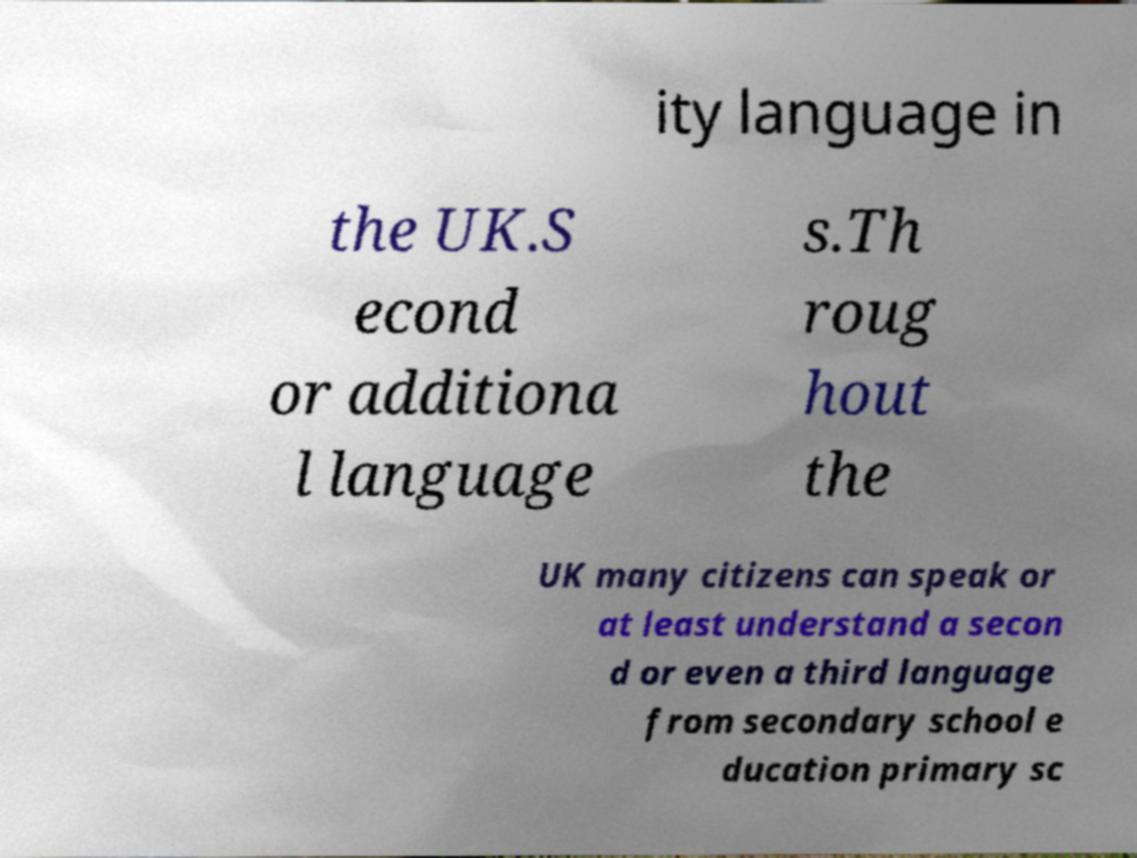Please read and relay the text visible in this image. What does it say? ity language in the UK.S econd or additiona l language s.Th roug hout the UK many citizens can speak or at least understand a secon d or even a third language from secondary school e ducation primary sc 